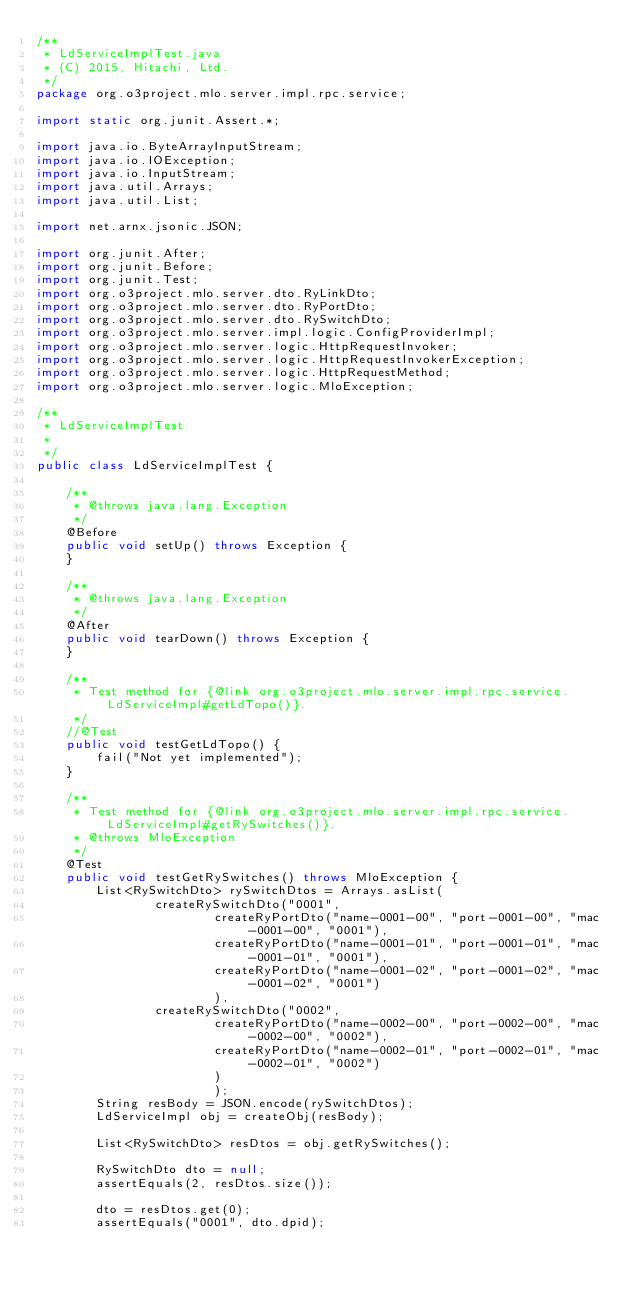<code> <loc_0><loc_0><loc_500><loc_500><_Java_>/**
 * LdServiceImplTest.java
 * (C) 2015, Hitachi, Ltd.
 */
package org.o3project.mlo.server.impl.rpc.service;

import static org.junit.Assert.*;

import java.io.ByteArrayInputStream;
import java.io.IOException;
import java.io.InputStream;
import java.util.Arrays;
import java.util.List;

import net.arnx.jsonic.JSON;

import org.junit.After;
import org.junit.Before;
import org.junit.Test;
import org.o3project.mlo.server.dto.RyLinkDto;
import org.o3project.mlo.server.dto.RyPortDto;
import org.o3project.mlo.server.dto.RySwitchDto;
import org.o3project.mlo.server.impl.logic.ConfigProviderImpl;
import org.o3project.mlo.server.logic.HttpRequestInvoker;
import org.o3project.mlo.server.logic.HttpRequestInvokerException;
import org.o3project.mlo.server.logic.HttpRequestMethod;
import org.o3project.mlo.server.logic.MloException;

/**
 * LdServiceImplTest
 *
 */
public class LdServiceImplTest {

	/**
	 * @throws java.lang.Exception
	 */
	@Before
	public void setUp() throws Exception {
	}

	/**
	 * @throws java.lang.Exception
	 */
	@After
	public void tearDown() throws Exception {
	}

	/**
	 * Test method for {@link org.o3project.mlo.server.impl.rpc.service.LdServiceImpl#getLdTopo()}.
	 */
	//@Test
	public void testGetLdTopo() {
		fail("Not yet implemented");
	}

	/**
	 * Test method for {@link org.o3project.mlo.server.impl.rpc.service.LdServiceImpl#getRySwitches()}.
	 * @throws MloException 
	 */
	@Test
	public void testGetRySwitches() throws MloException {
		List<RySwitchDto> rySwitchDtos = Arrays.asList(
				createRySwitchDto("0001", 
						createRyPortDto("name-0001-00", "port-0001-00", "mac-0001-00", "0001"),
						createRyPortDto("name-0001-01", "port-0001-01", "mac-0001-01", "0001"),
						createRyPortDto("name-0001-02", "port-0001-02", "mac-0001-02", "0001")
						),
				createRySwitchDto("0002", 
						createRyPortDto("name-0002-00", "port-0002-00", "mac-0002-00", "0002"),
						createRyPortDto("name-0002-01", "port-0002-01", "mac-0002-01", "0002")
						)
						);
		String resBody = JSON.encode(rySwitchDtos);
		LdServiceImpl obj = createObj(resBody);

		List<RySwitchDto> resDtos = obj.getRySwitches();
		
		RySwitchDto dto = null;
		assertEquals(2, resDtos.size());
		
		dto = resDtos.get(0);
		assertEquals("0001", dto.dpid);</code> 